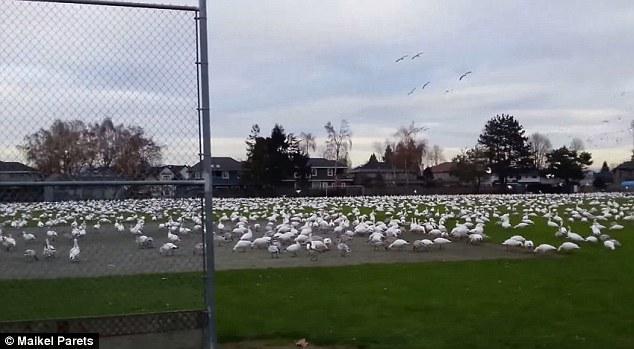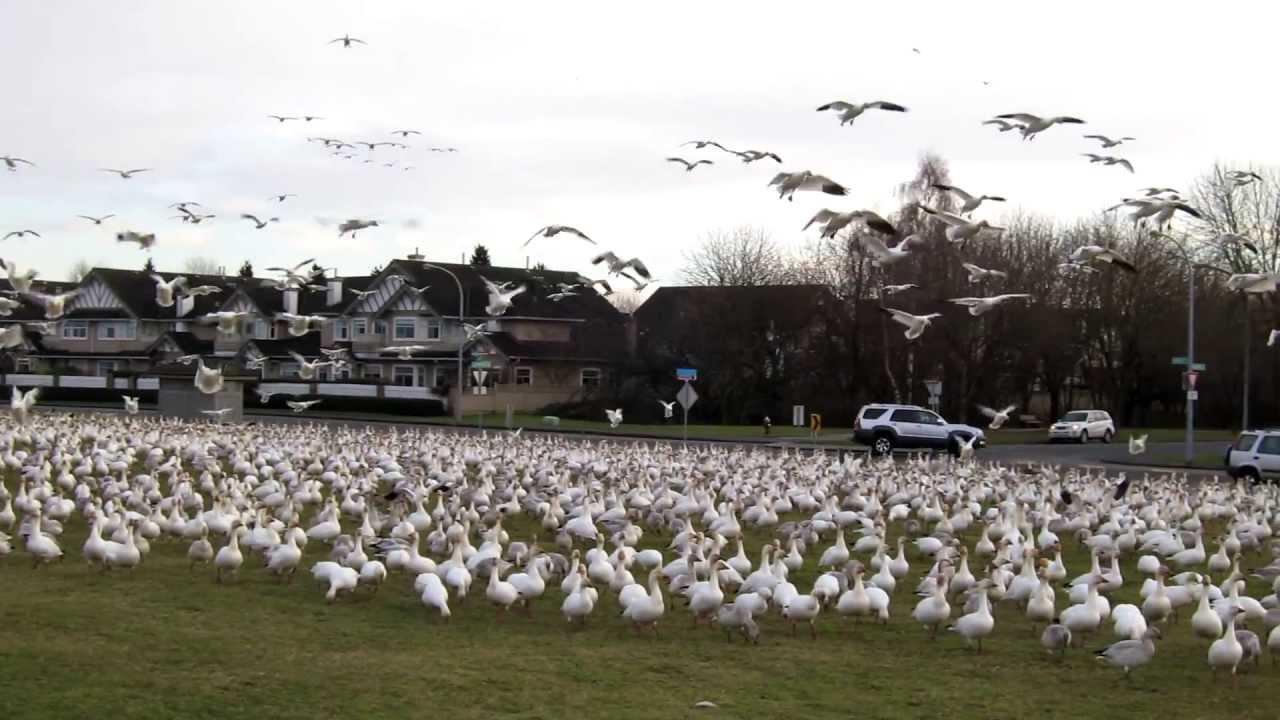The first image is the image on the left, the second image is the image on the right. Considering the images on both sides, is "All birds are flying in the sky above a green field in one image." valid? Answer yes or no. No. 